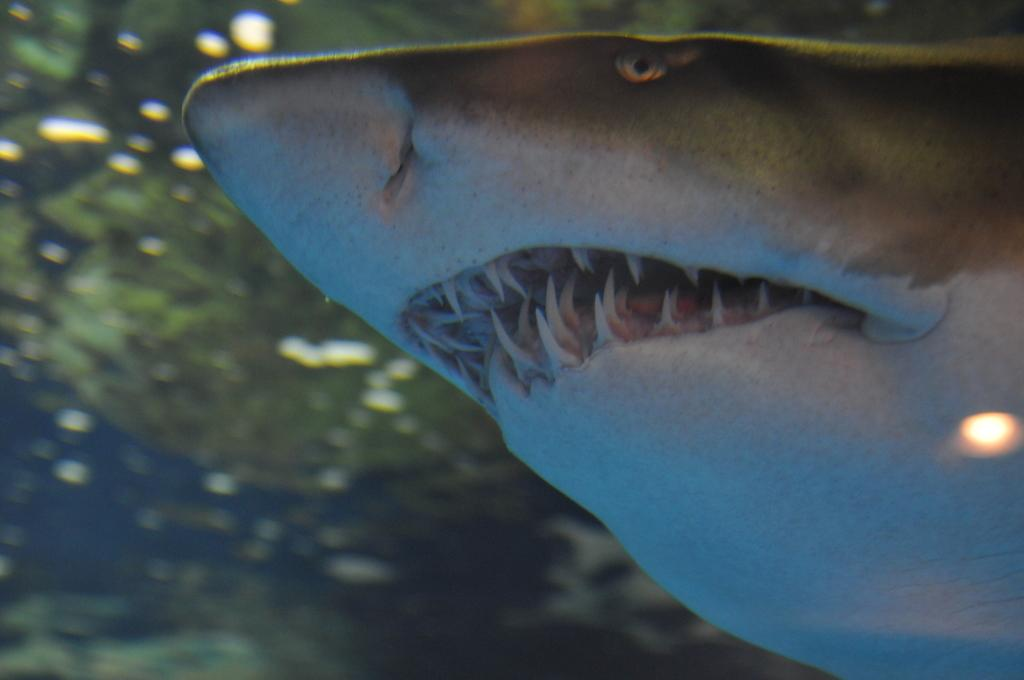What animal is present in the image? There is a shark in the image. Where is the shark located? The shark is in the water. What type of motion can be seen in the image involving a bear and boys? There is no bear or boys present in the image, and therefore no such motion can be observed. 